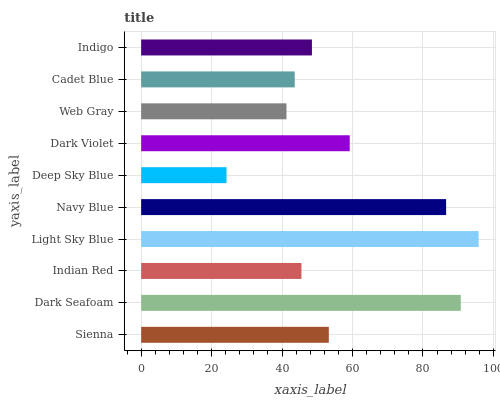Is Deep Sky Blue the minimum?
Answer yes or no. Yes. Is Light Sky Blue the maximum?
Answer yes or no. Yes. Is Dark Seafoam the minimum?
Answer yes or no. No. Is Dark Seafoam the maximum?
Answer yes or no. No. Is Dark Seafoam greater than Sienna?
Answer yes or no. Yes. Is Sienna less than Dark Seafoam?
Answer yes or no. Yes. Is Sienna greater than Dark Seafoam?
Answer yes or no. No. Is Dark Seafoam less than Sienna?
Answer yes or no. No. Is Sienna the high median?
Answer yes or no. Yes. Is Indigo the low median?
Answer yes or no. Yes. Is Dark Seafoam the high median?
Answer yes or no. No. Is Indian Red the low median?
Answer yes or no. No. 